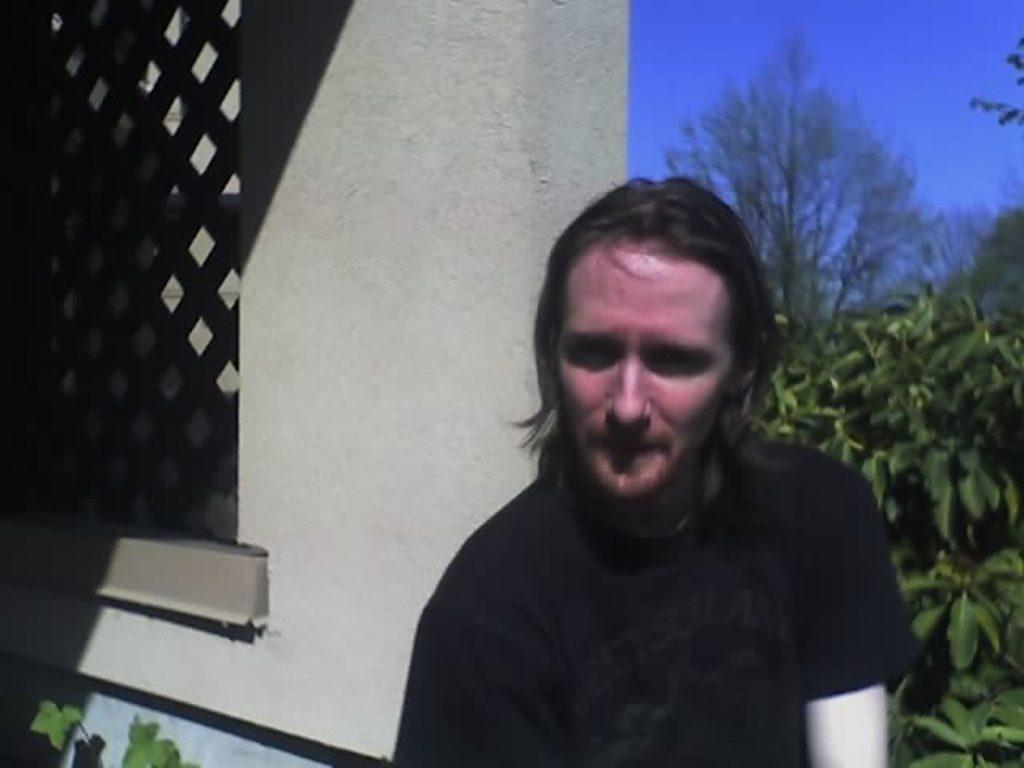Who is present in the image? There is a man in the image. What is the man wearing? The man is wearing a black t-shirt. What is located beside the man? There is a wall beside the man. What can be seen in the background of the image? There are trees and plants in the background of the image. What is visible at the top of the image? The sky is visible at the top of the image. Can you tell me how many friends are standing next to the man in the image? A: There is no mention of a friend or any other person in the image besides the man. What type of leaf is falling from the tree in the image? There is no leaf falling from the tree in the image; only trees and plants are visible in the background. 